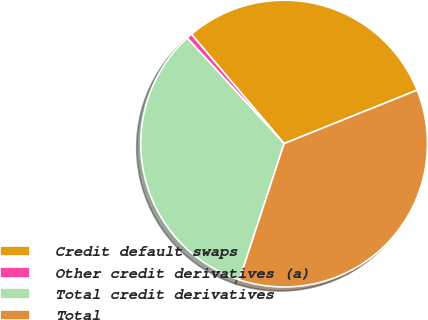Convert chart to OTSL. <chart><loc_0><loc_0><loc_500><loc_500><pie_chart><fcel>Credit default swaps<fcel>Other credit derivatives (a)<fcel>Total credit derivatives<fcel>Total<nl><fcel>30.11%<fcel>0.63%<fcel>33.12%<fcel>36.13%<nl></chart> 